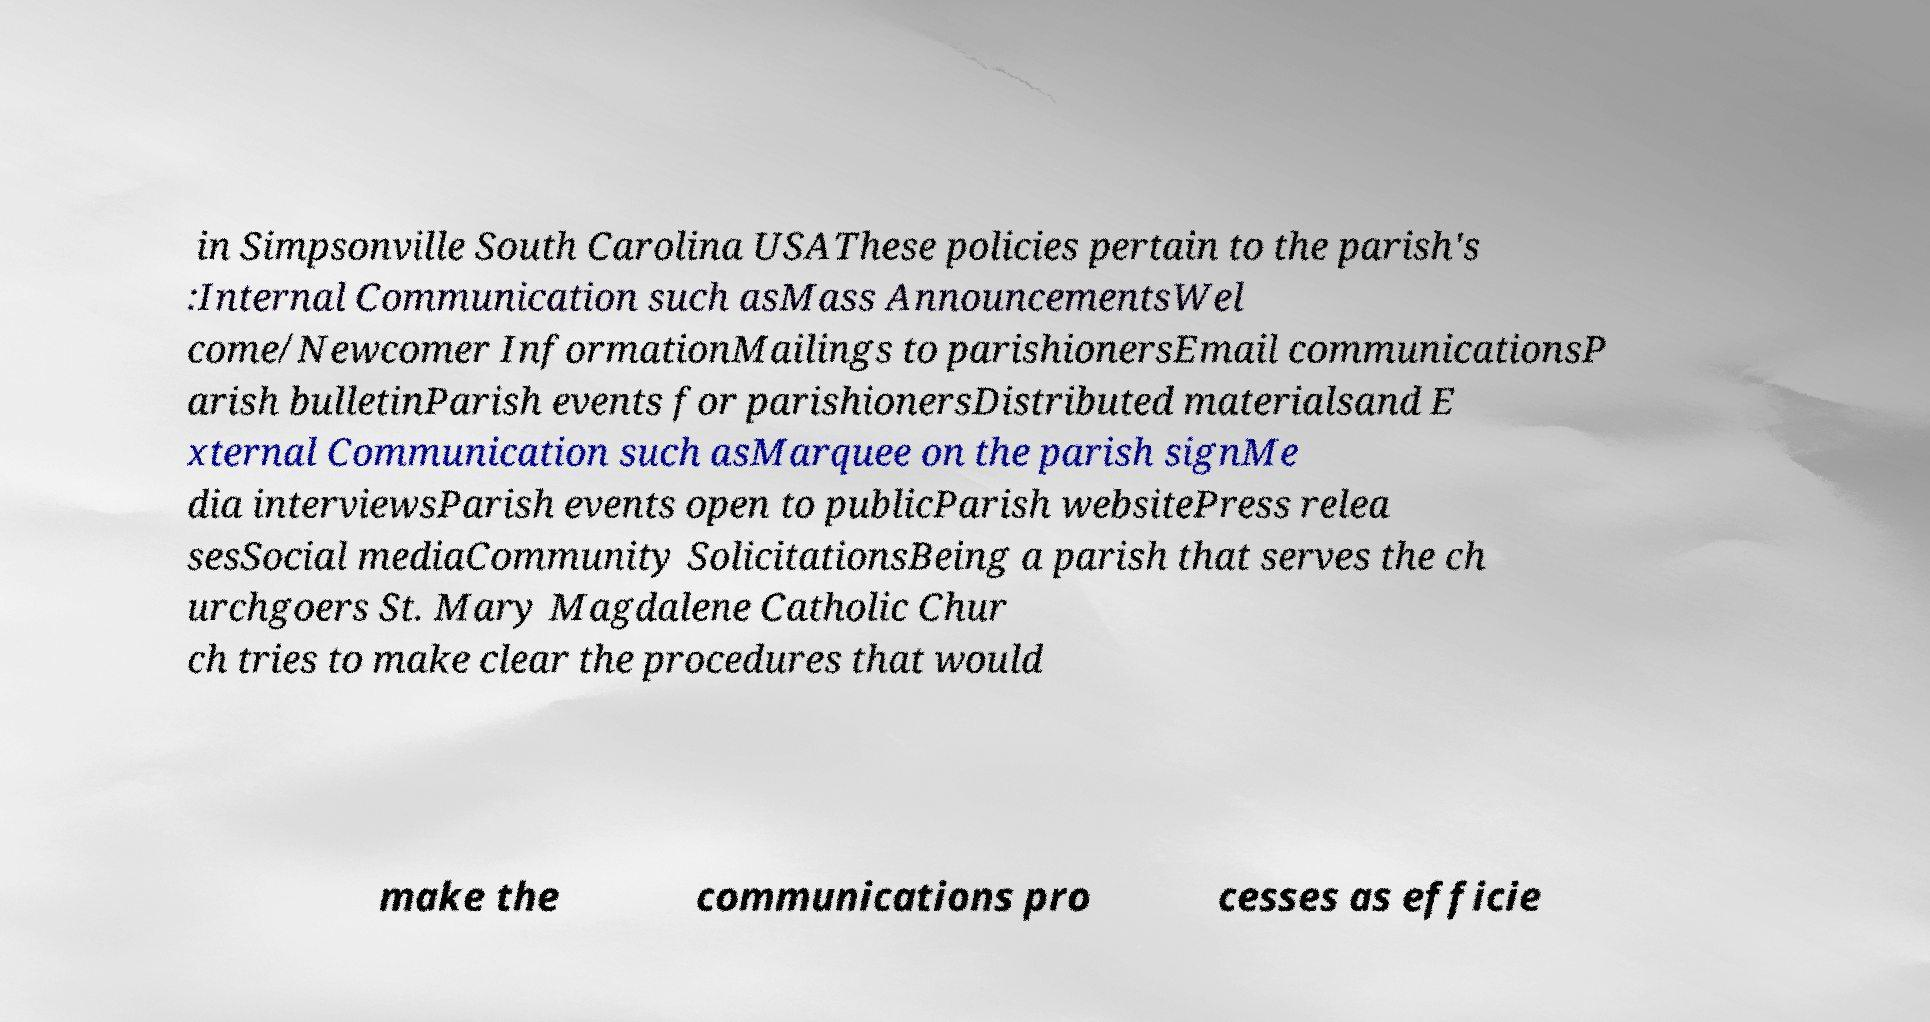Please read and relay the text visible in this image. What does it say? in Simpsonville South Carolina USAThese policies pertain to the parish's :Internal Communication such asMass AnnouncementsWel come/Newcomer InformationMailings to parishionersEmail communicationsP arish bulletinParish events for parishionersDistributed materialsand E xternal Communication such asMarquee on the parish signMe dia interviewsParish events open to publicParish websitePress relea sesSocial mediaCommunity SolicitationsBeing a parish that serves the ch urchgoers St. Mary Magdalene Catholic Chur ch tries to make clear the procedures that would make the communications pro cesses as efficie 